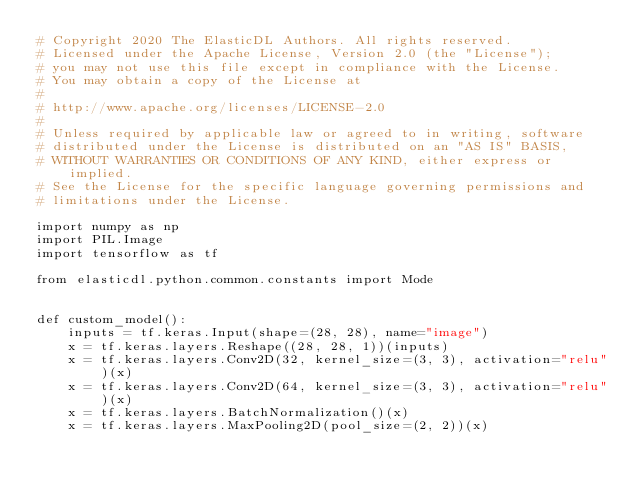Convert code to text. <code><loc_0><loc_0><loc_500><loc_500><_Python_># Copyright 2020 The ElasticDL Authors. All rights reserved.
# Licensed under the Apache License, Version 2.0 (the "License");
# you may not use this file except in compliance with the License.
# You may obtain a copy of the License at
#
# http://www.apache.org/licenses/LICENSE-2.0
#
# Unless required by applicable law or agreed to in writing, software
# distributed under the License is distributed on an "AS IS" BASIS,
# WITHOUT WARRANTIES OR CONDITIONS OF ANY KIND, either express or implied.
# See the License for the specific language governing permissions and
# limitations under the License.

import numpy as np
import PIL.Image
import tensorflow as tf

from elasticdl.python.common.constants import Mode


def custom_model():
    inputs = tf.keras.Input(shape=(28, 28), name="image")
    x = tf.keras.layers.Reshape((28, 28, 1))(inputs)
    x = tf.keras.layers.Conv2D(32, kernel_size=(3, 3), activation="relu")(x)
    x = tf.keras.layers.Conv2D(64, kernel_size=(3, 3), activation="relu")(x)
    x = tf.keras.layers.BatchNormalization()(x)
    x = tf.keras.layers.MaxPooling2D(pool_size=(2, 2))(x)</code> 